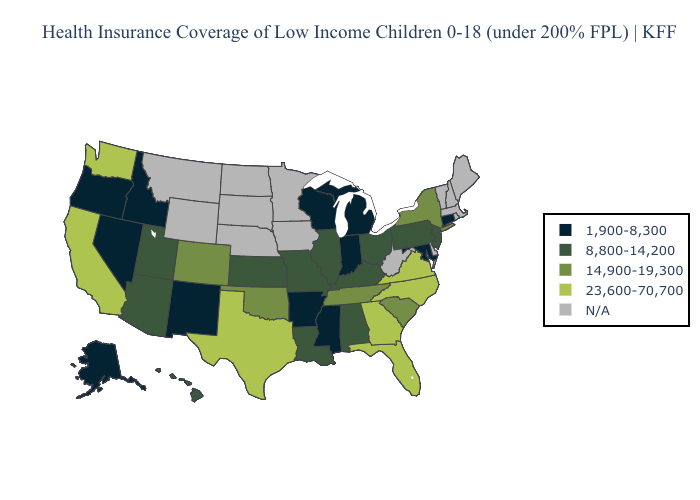Name the states that have a value in the range 23,600-70,700?
Keep it brief. California, Florida, Georgia, North Carolina, Texas, Virginia, Washington. Name the states that have a value in the range 14,900-19,300?
Concise answer only. Colorado, New York, Oklahoma, South Carolina, Tennessee. Name the states that have a value in the range 23,600-70,700?
Answer briefly. California, Florida, Georgia, North Carolina, Texas, Virginia, Washington. Among the states that border Wyoming , does Utah have the lowest value?
Write a very short answer. No. How many symbols are there in the legend?
Quick response, please. 5. Which states have the highest value in the USA?
Give a very brief answer. California, Florida, Georgia, North Carolina, Texas, Virginia, Washington. What is the value of Delaware?
Give a very brief answer. N/A. What is the value of Utah?
Answer briefly. 8,800-14,200. Which states have the lowest value in the South?
Give a very brief answer. Arkansas, Maryland, Mississippi. Name the states that have a value in the range N/A?
Give a very brief answer. Delaware, Iowa, Maine, Massachusetts, Minnesota, Montana, Nebraska, New Hampshire, North Dakota, Rhode Island, South Dakota, Vermont, West Virginia, Wyoming. What is the value of Louisiana?
Be succinct. 8,800-14,200. What is the value of New Mexico?
Concise answer only. 1,900-8,300. Does Missouri have the lowest value in the USA?
Give a very brief answer. No. 